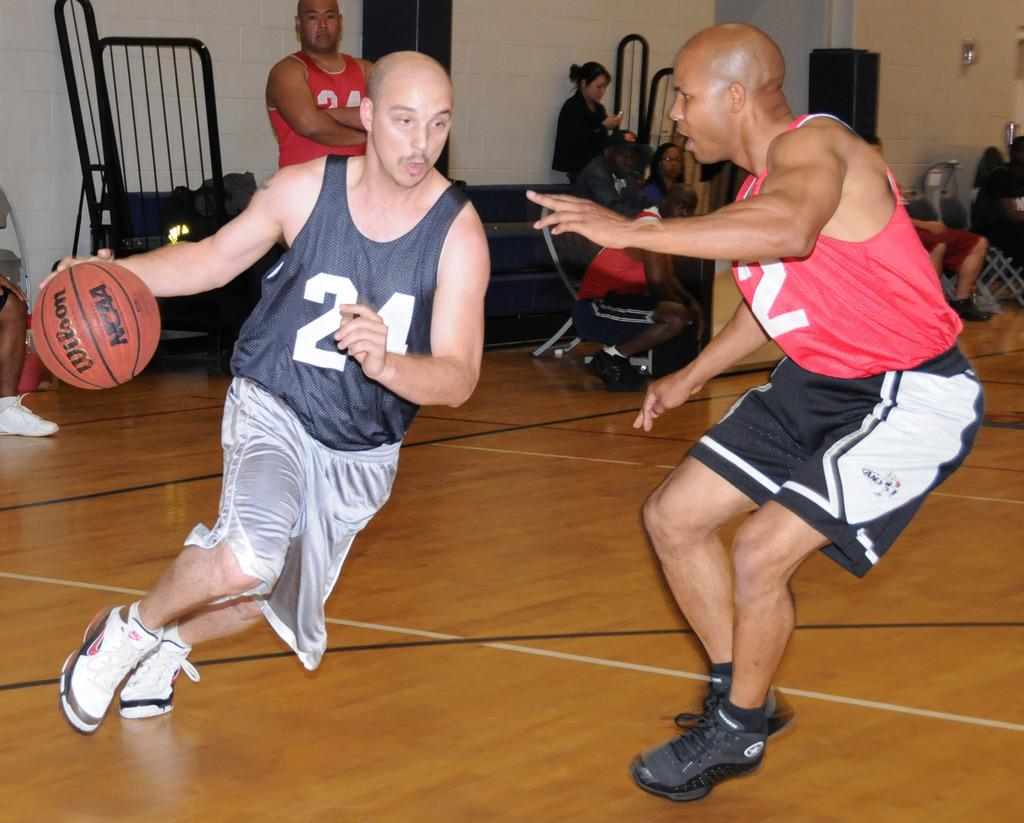<image>
Relay a brief, clear account of the picture shown. A man wearing 24 basketball jersey is rushing around another player. 